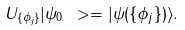Convert formula to latex. <formula><loc_0><loc_0><loc_500><loc_500>U _ { \{ \phi _ { j } \} } | \psi _ { 0 } \ > = | \psi ( \{ \phi _ { j } \} ) \rangle .</formula> 